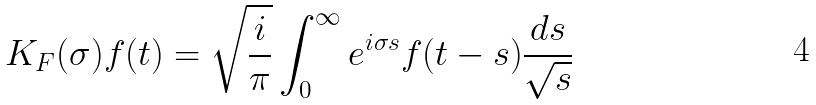<formula> <loc_0><loc_0><loc_500><loc_500>K _ { F } ( \sigma ) f ( t ) = \sqrt { \frac { i } { \pi } } \int _ { 0 } ^ { \infty } e ^ { i \sigma s } f ( t - s ) \frac { d s } { \sqrt { s } }</formula> 